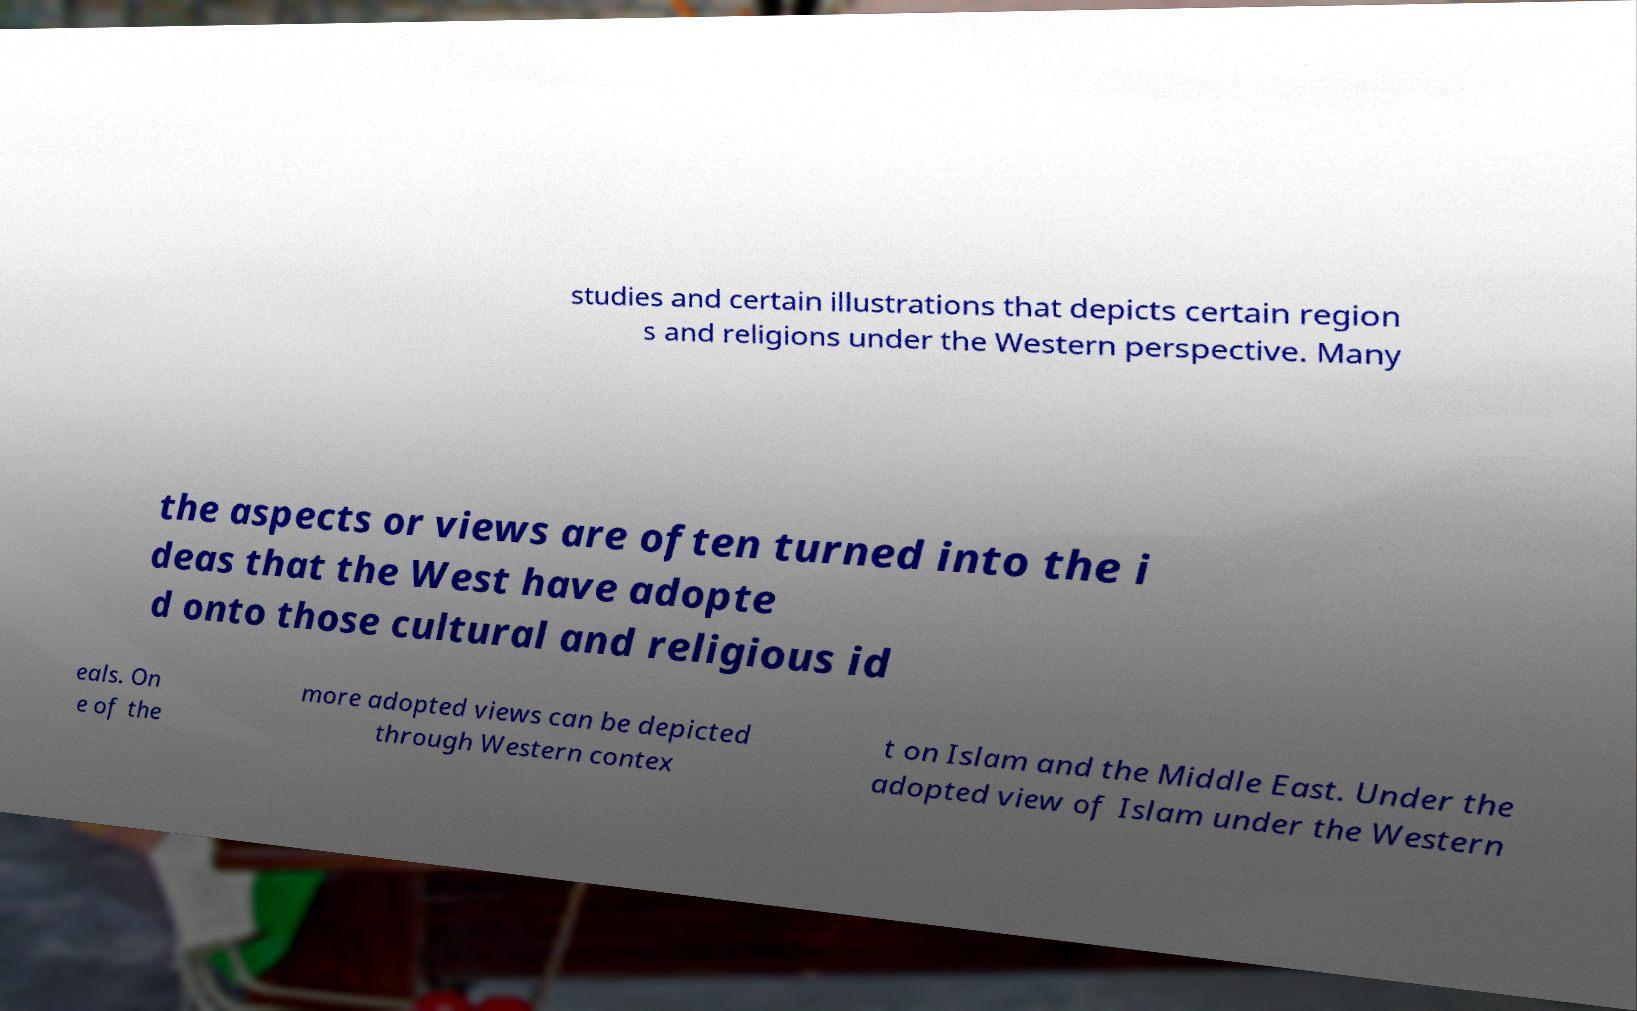There's text embedded in this image that I need extracted. Can you transcribe it verbatim? studies and certain illustrations that depicts certain region s and religions under the Western perspective. Many the aspects or views are often turned into the i deas that the West have adopte d onto those cultural and religious id eals. On e of the more adopted views can be depicted through Western contex t on Islam and the Middle East. Under the adopted view of Islam under the Western 